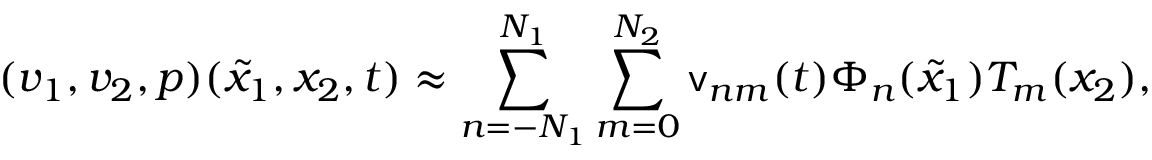<formula> <loc_0><loc_0><loc_500><loc_500>( v _ { 1 } , v _ { 2 } , p ) ( \tilde { x } _ { 1 } , x _ { 2 } , t ) \approx \sum _ { n = - N _ { 1 } } ^ { N _ { 1 } } \sum _ { m = 0 } ^ { N _ { 2 } } v _ { n m } ( t ) \Phi _ { n } ( \tilde { x } _ { 1 } ) T _ { m } ( x _ { 2 } ) ,</formula> 